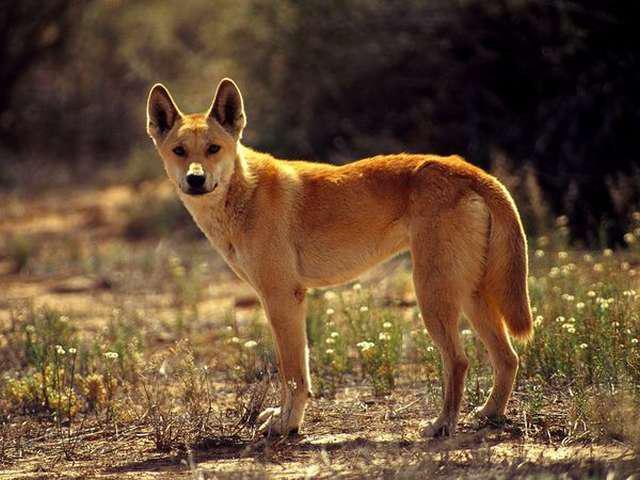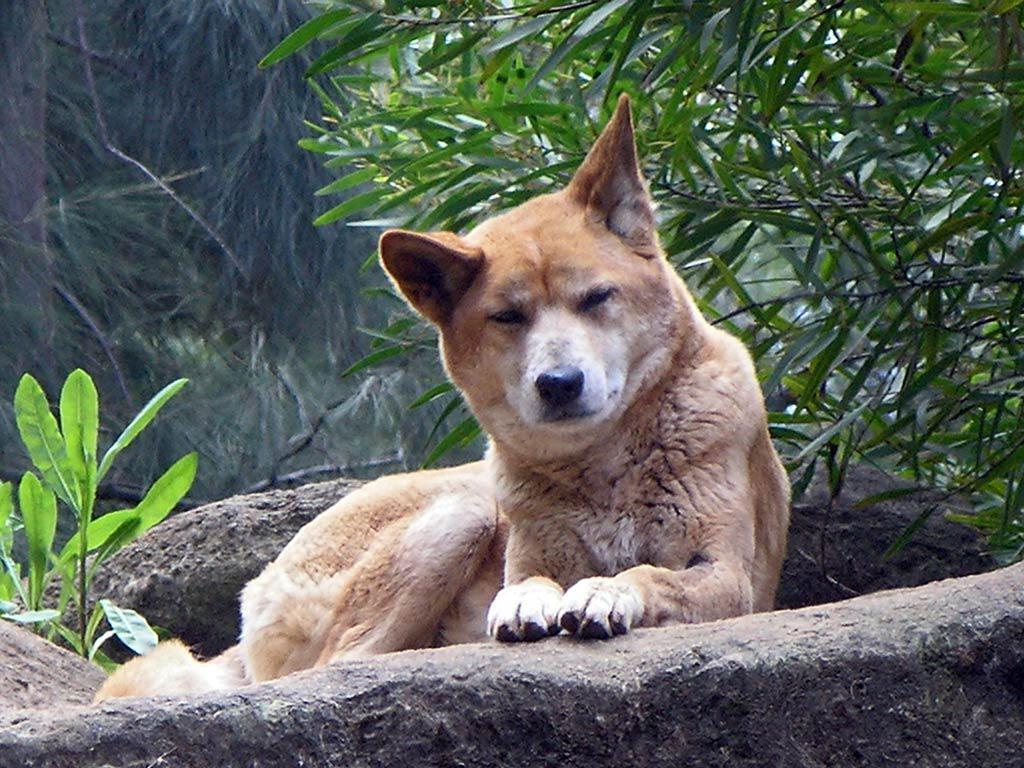The first image is the image on the left, the second image is the image on the right. Considering the images on both sides, is "There is an animal lying down in one of the images" valid? Answer yes or no. Yes. The first image is the image on the left, the second image is the image on the right. Considering the images on both sides, is "A canine is on the ground in a resting pose, in one image." valid? Answer yes or no. Yes. 